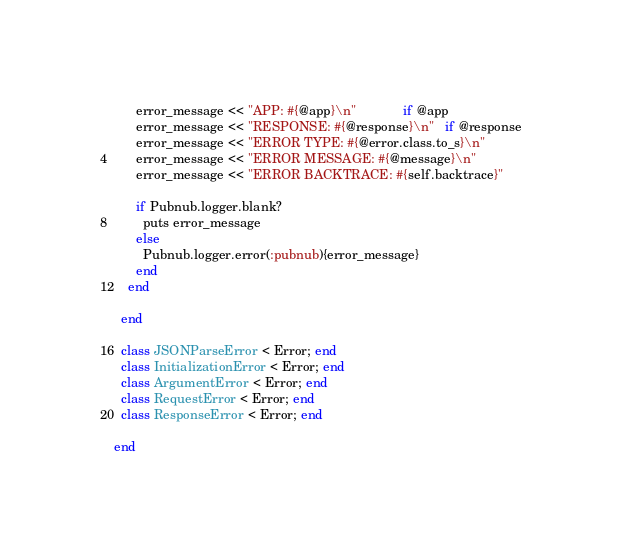<code> <loc_0><loc_0><loc_500><loc_500><_Ruby_>      error_message << "APP: #{@app}\n"             if @app
      error_message << "RESPONSE: #{@response}\n"   if @response
      error_message << "ERROR TYPE: #{@error.class.to_s}\n"
      error_message << "ERROR MESSAGE: #{@message}\n"
      error_message << "ERROR BACKTRACE: #{self.backtrace}"

      if Pubnub.logger.blank?
        puts error_message
      else
        Pubnub.logger.error(:pubnub){error_message}
      end
    end

  end

  class JSONParseError < Error; end
  class InitializationError < Error; end
  class ArgumentError < Error; end
  class RequestError < Error; end
  class ResponseError < Error; end

end</code> 